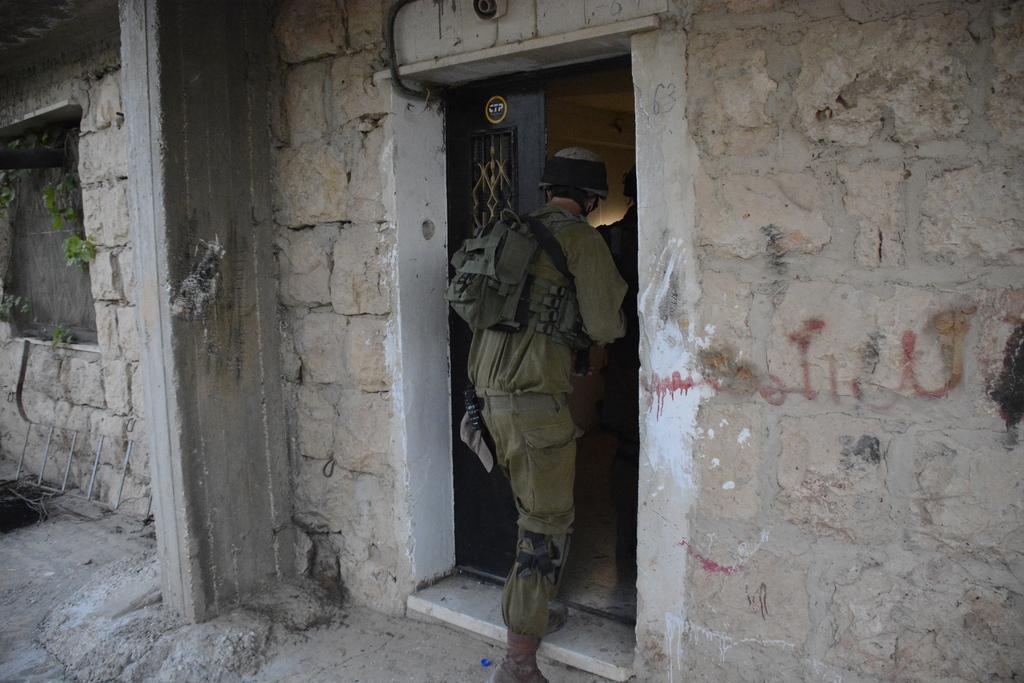Please provide a concise description of this image. In this image we can see the wall with the door and the pillar and we can see a person going inside the building. 